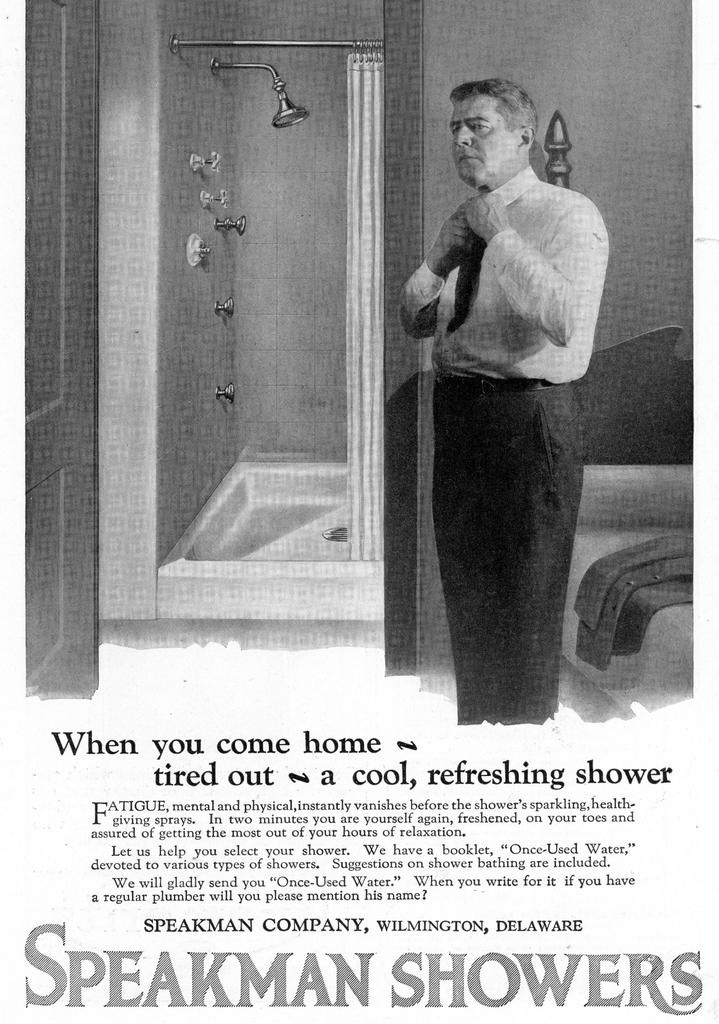Where is the speakman company located?
Your response must be concise. Wilmington, delaware. What brand is this advertisement for?
Give a very brief answer. Speakman showers. 